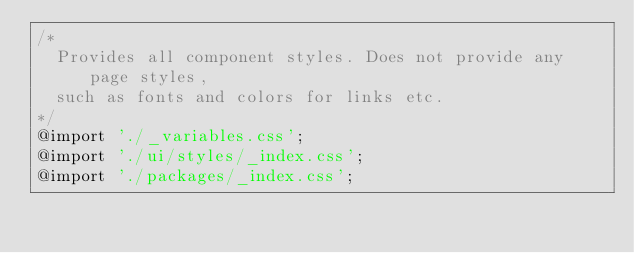Convert code to text. <code><loc_0><loc_0><loc_500><loc_500><_CSS_>/*
  Provides all component styles. Does not provide any page styles,
  such as fonts and colors for links etc.
*/
@import './_variables.css';
@import './ui/styles/_index.css';
@import './packages/_index.css';
</code> 